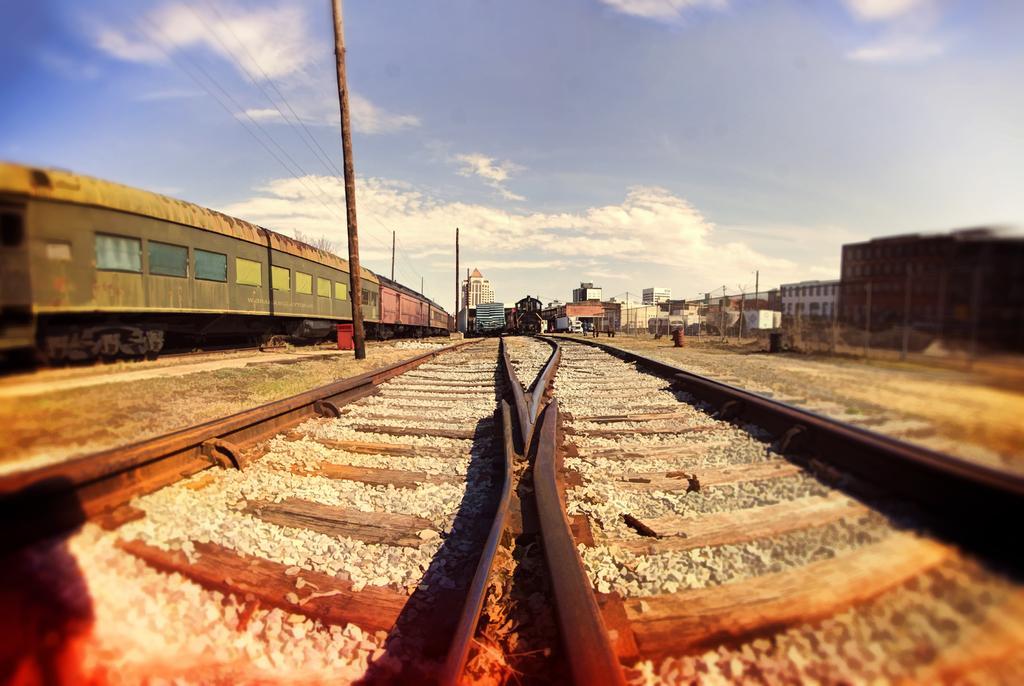In one or two sentences, can you explain what this image depicts? In this image there are train tracks, on the track there are trains, in the background there are houses and a sky. 